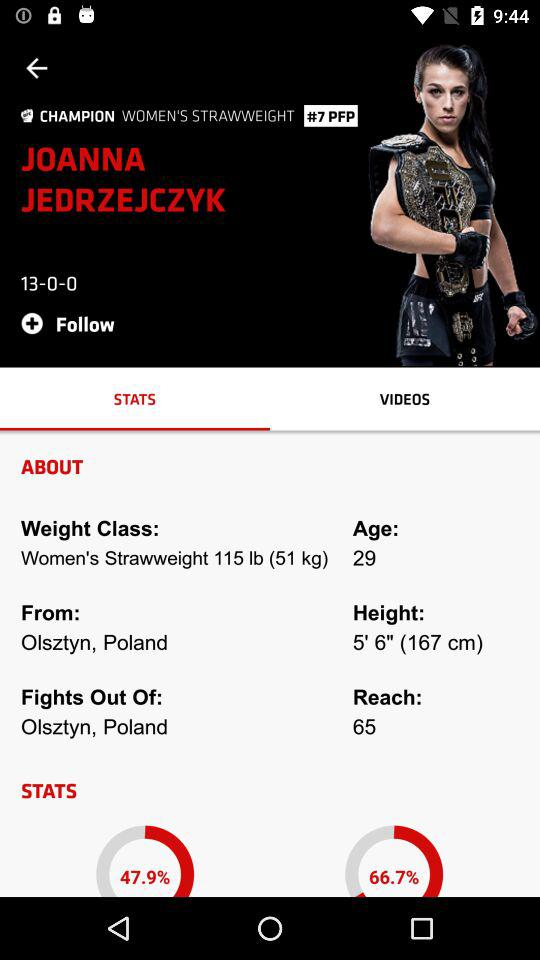What is the height of Joanna Jedrzejczyk? The height is 5' 6" (167 cm). 